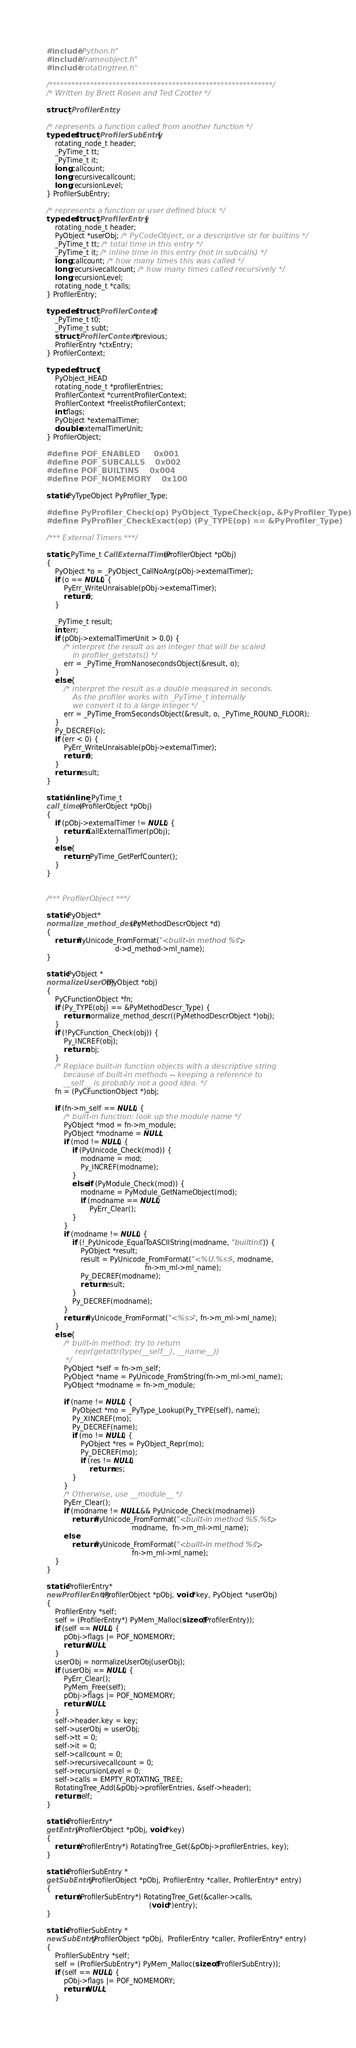<code> <loc_0><loc_0><loc_500><loc_500><_C_>#include "Python.h"
#include "frameobject.h"
#include "rotatingtree.h"

/************************************************************/
/* Written by Brett Rosen and Ted Czotter */

struct _ProfilerEntry;

/* represents a function called from another function */
typedef struct _ProfilerSubEntry {
    rotating_node_t header;
    _PyTime_t tt;
    _PyTime_t it;
    long callcount;
    long recursivecallcount;
    long recursionLevel;
} ProfilerSubEntry;

/* represents a function or user defined block */
typedef struct _ProfilerEntry {
    rotating_node_t header;
    PyObject *userObj; /* PyCodeObject, or a descriptive str for builtins */
    _PyTime_t tt; /* total time in this entry */
    _PyTime_t it; /* inline time in this entry (not in subcalls) */
    long callcount; /* how many times this was called */
    long recursivecallcount; /* how many times called recursively */
    long recursionLevel;
    rotating_node_t *calls;
} ProfilerEntry;

typedef struct _ProfilerContext {
    _PyTime_t t0;
    _PyTime_t subt;
    struct _ProfilerContext *previous;
    ProfilerEntry *ctxEntry;
} ProfilerContext;

typedef struct {
    PyObject_HEAD
    rotating_node_t *profilerEntries;
    ProfilerContext *currentProfilerContext;
    ProfilerContext *freelistProfilerContext;
    int flags;
    PyObject *externalTimer;
    double externalTimerUnit;
} ProfilerObject;

#define POF_ENABLED     0x001
#define POF_SUBCALLS    0x002
#define POF_BUILTINS    0x004
#define POF_NOMEMORY    0x100

static PyTypeObject PyProfiler_Type;

#define PyProfiler_Check(op) PyObject_TypeCheck(op, &PyProfiler_Type)
#define PyProfiler_CheckExact(op) (Py_TYPE(op) == &PyProfiler_Type)

/*** External Timers ***/

static _PyTime_t CallExternalTimer(ProfilerObject *pObj)
{
    PyObject *o = _PyObject_CallNoArg(pObj->externalTimer);
    if (o == NULL) {
        PyErr_WriteUnraisable(pObj->externalTimer);
        return 0;
    }

    _PyTime_t result;
    int err;
    if (pObj->externalTimerUnit > 0.0) {
        /* interpret the result as an integer that will be scaled
           in profiler_getstats() */
        err = _PyTime_FromNanosecondsObject(&result, o);
    }
    else {
        /* interpret the result as a double measured in seconds.
           As the profiler works with _PyTime_t internally
           we convert it to a large integer */
        err = _PyTime_FromSecondsObject(&result, o, _PyTime_ROUND_FLOOR);
    }
    Py_DECREF(o);
    if (err < 0) {
        PyErr_WriteUnraisable(pObj->externalTimer);
        return 0;
    }
    return result;
}

static inline _PyTime_t
call_timer(ProfilerObject *pObj)
{
    if (pObj->externalTimer != NULL) {
        return CallExternalTimer(pObj);
    }
    else {
        return _PyTime_GetPerfCounter();
    }
}


/*** ProfilerObject ***/

static PyObject*
normalize_method_descr(PyMethodDescrObject *d)
{
    return PyUnicode_FromFormat("<built-in method %s>",
                                d->d_method->ml_name);
}

static PyObject *
normalizeUserObj(PyObject *obj)
{
    PyCFunctionObject *fn;
    if (Py_TYPE(obj) == &PyMethodDescr_Type) {
        return normalize_method_descr((PyMethodDescrObject *)obj);
    }
    if (!PyCFunction_Check(obj)) {
        Py_INCREF(obj);
        return obj;
    }
    /* Replace built-in function objects with a descriptive string
       because of built-in methods -- keeping a reference to
       __self__ is probably not a good idea. */
    fn = (PyCFunctionObject *)obj;

    if (fn->m_self == NULL) {
        /* built-in function: look up the module name */
        PyObject *mod = fn->m_module;
        PyObject *modname = NULL;
        if (mod != NULL) {
            if (PyUnicode_Check(mod)) {
                modname = mod;
                Py_INCREF(modname);
            }
            else if (PyModule_Check(mod)) {
                modname = PyModule_GetNameObject(mod);
                if (modname == NULL)
                    PyErr_Clear();
            }
        }
        if (modname != NULL) {
            if (!_PyUnicode_EqualToASCIIString(modname, "builtins")) {
                PyObject *result;
                result = PyUnicode_FromFormat("<%U.%s>", modname,
                                              fn->m_ml->ml_name);
                Py_DECREF(modname);
                return result;
            }
            Py_DECREF(modname);
        }
        return PyUnicode_FromFormat("<%s>", fn->m_ml->ml_name);
    }
    else {
        /* built-in method: try to return
            repr(getattr(type(__self__), __name__))
        */
        PyObject *self = fn->m_self;
        PyObject *name = PyUnicode_FromString(fn->m_ml->ml_name);
        PyObject *modname = fn->m_module;

        if (name != NULL) {
            PyObject *mo = _PyType_Lookup(Py_TYPE(self), name);
            Py_XINCREF(mo);
            Py_DECREF(name);
            if (mo != NULL) {
                PyObject *res = PyObject_Repr(mo);
                Py_DECREF(mo);
                if (res != NULL)
                    return res;
            }
        }
        /* Otherwise, use __module__ */
        PyErr_Clear();
        if (modname != NULL && PyUnicode_Check(modname))
            return PyUnicode_FromFormat("<built-in method %S.%s>",
                                        modname,  fn->m_ml->ml_name);
        else
            return PyUnicode_FromFormat("<built-in method %s>",
                                        fn->m_ml->ml_name);
    }
}

static ProfilerEntry*
newProfilerEntry(ProfilerObject *pObj, void *key, PyObject *userObj)
{
    ProfilerEntry *self;
    self = (ProfilerEntry*) PyMem_Malloc(sizeof(ProfilerEntry));
    if (self == NULL) {
        pObj->flags |= POF_NOMEMORY;
        return NULL;
    }
    userObj = normalizeUserObj(userObj);
    if (userObj == NULL) {
        PyErr_Clear();
        PyMem_Free(self);
        pObj->flags |= POF_NOMEMORY;
        return NULL;
    }
    self->header.key = key;
    self->userObj = userObj;
    self->tt = 0;
    self->it = 0;
    self->callcount = 0;
    self->recursivecallcount = 0;
    self->recursionLevel = 0;
    self->calls = EMPTY_ROTATING_TREE;
    RotatingTree_Add(&pObj->profilerEntries, &self->header);
    return self;
}

static ProfilerEntry*
getEntry(ProfilerObject *pObj, void *key)
{
    return (ProfilerEntry*) RotatingTree_Get(&pObj->profilerEntries, key);
}

static ProfilerSubEntry *
getSubEntry(ProfilerObject *pObj, ProfilerEntry *caller, ProfilerEntry* entry)
{
    return (ProfilerSubEntry*) RotatingTree_Get(&caller->calls,
                                                (void *)entry);
}

static ProfilerSubEntry *
newSubEntry(ProfilerObject *pObj,  ProfilerEntry *caller, ProfilerEntry* entry)
{
    ProfilerSubEntry *self;
    self = (ProfilerSubEntry*) PyMem_Malloc(sizeof(ProfilerSubEntry));
    if (self == NULL) {
        pObj->flags |= POF_NOMEMORY;
        return NULL;
    }</code> 